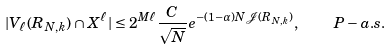<formula> <loc_0><loc_0><loc_500><loc_500>| V _ { \ell } ( R _ { N , k } ) \cap X ^ { \ell } | \leq 2 ^ { M \ell } \frac { C } { \sqrt { N } } e ^ { - ( 1 - \alpha ) N \mathcal { J } ( R _ { N , k } ) } , \quad P - a . s .</formula> 